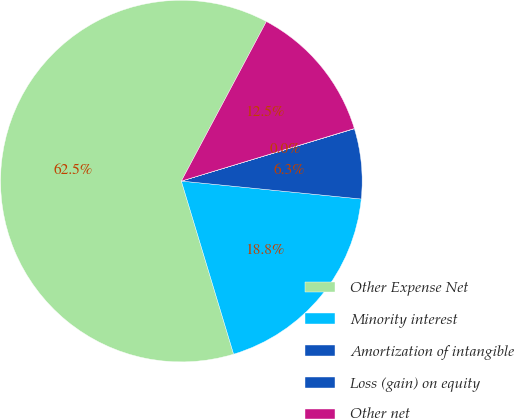Convert chart to OTSL. <chart><loc_0><loc_0><loc_500><loc_500><pie_chart><fcel>Other Expense Net<fcel>Minority interest<fcel>Amortization of intangible<fcel>Loss (gain) on equity<fcel>Other net<nl><fcel>62.46%<fcel>18.75%<fcel>6.26%<fcel>0.02%<fcel>12.51%<nl></chart> 